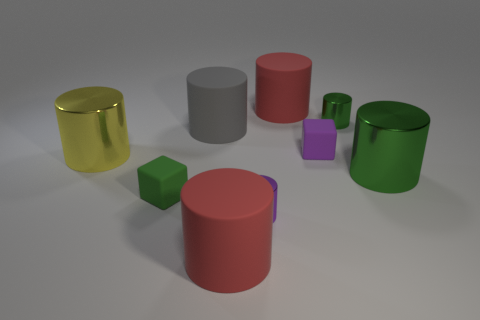How many objects are either small green rubber things or purple matte cubes that are in front of the gray cylinder?
Your answer should be very brief. 2. Are there fewer large red matte things than purple shiny things?
Your response must be concise. No. Are there more large gray metallic balls than red rubber objects?
Make the answer very short. No. How many other things are made of the same material as the purple cylinder?
Offer a terse response. 3. There is a tiny green thing that is in front of the small metallic cylinder behind the big green shiny cylinder; what number of large metal things are to the right of it?
Provide a succinct answer. 1. What number of metallic objects are either small cylinders or big green objects?
Your answer should be compact. 3. How big is the red rubber cylinder that is in front of the small cylinder behind the large gray rubber cylinder?
Give a very brief answer. Large. There is a small rubber thing that is on the right side of the tiny green rubber block; is its color the same as the tiny cube that is to the left of the purple cylinder?
Make the answer very short. No. What color is the thing that is both left of the large gray rubber cylinder and in front of the large yellow metal cylinder?
Offer a terse response. Green. Is the small green cube made of the same material as the large yellow cylinder?
Your answer should be compact. No. 